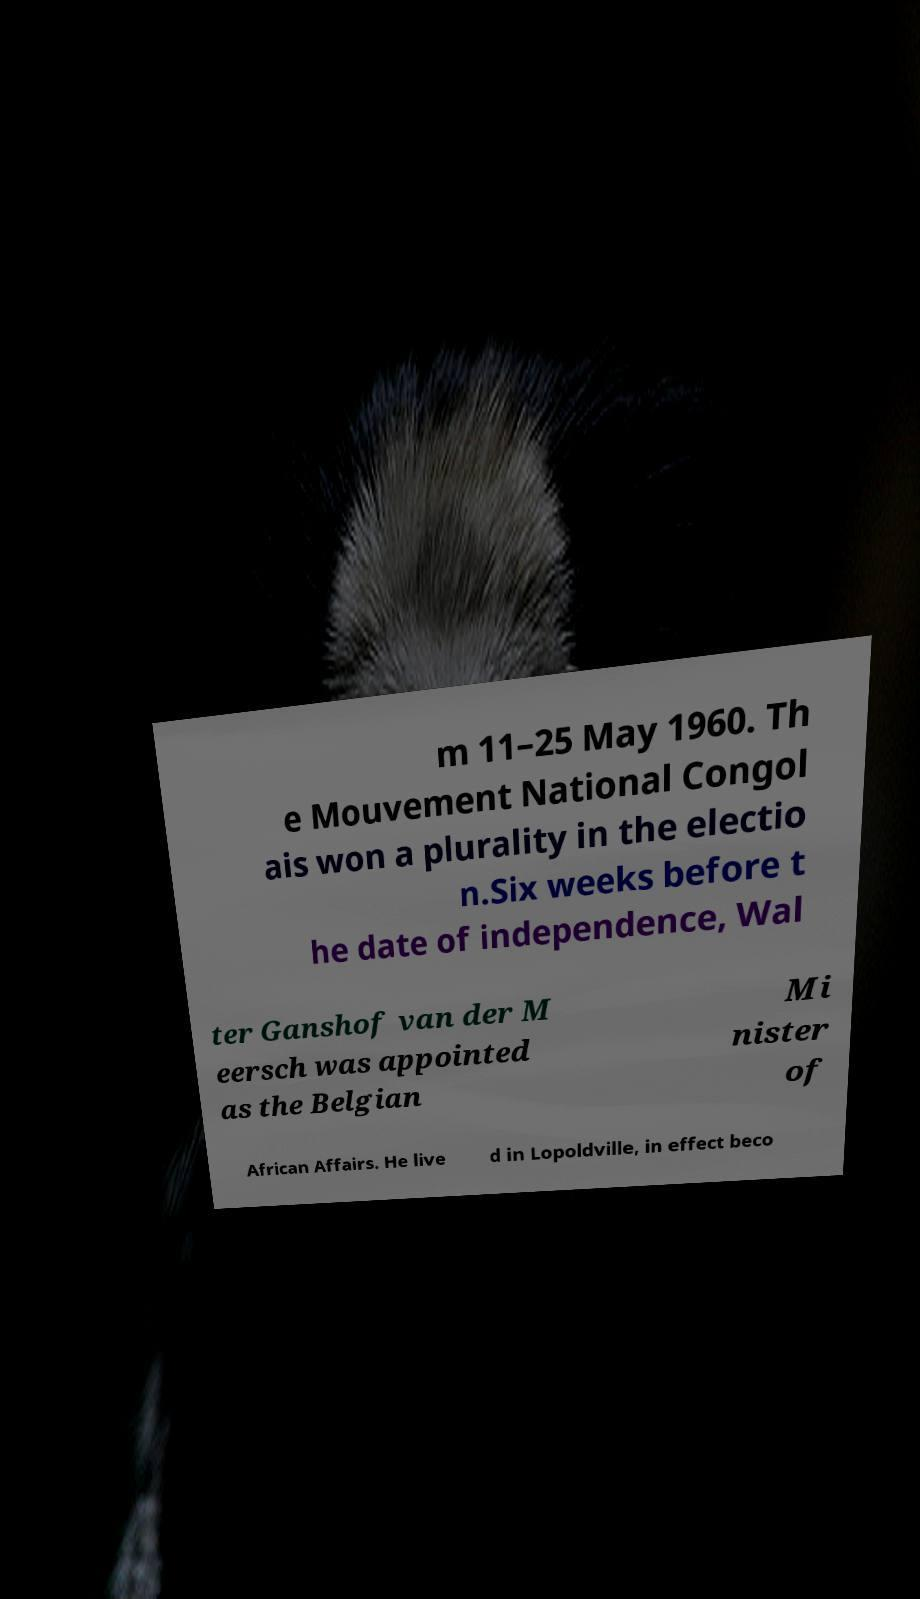Could you assist in decoding the text presented in this image and type it out clearly? m 11–25 May 1960. Th e Mouvement National Congol ais won a plurality in the electio n.Six weeks before t he date of independence, Wal ter Ganshof van der M eersch was appointed as the Belgian Mi nister of African Affairs. He live d in Lopoldville, in effect beco 